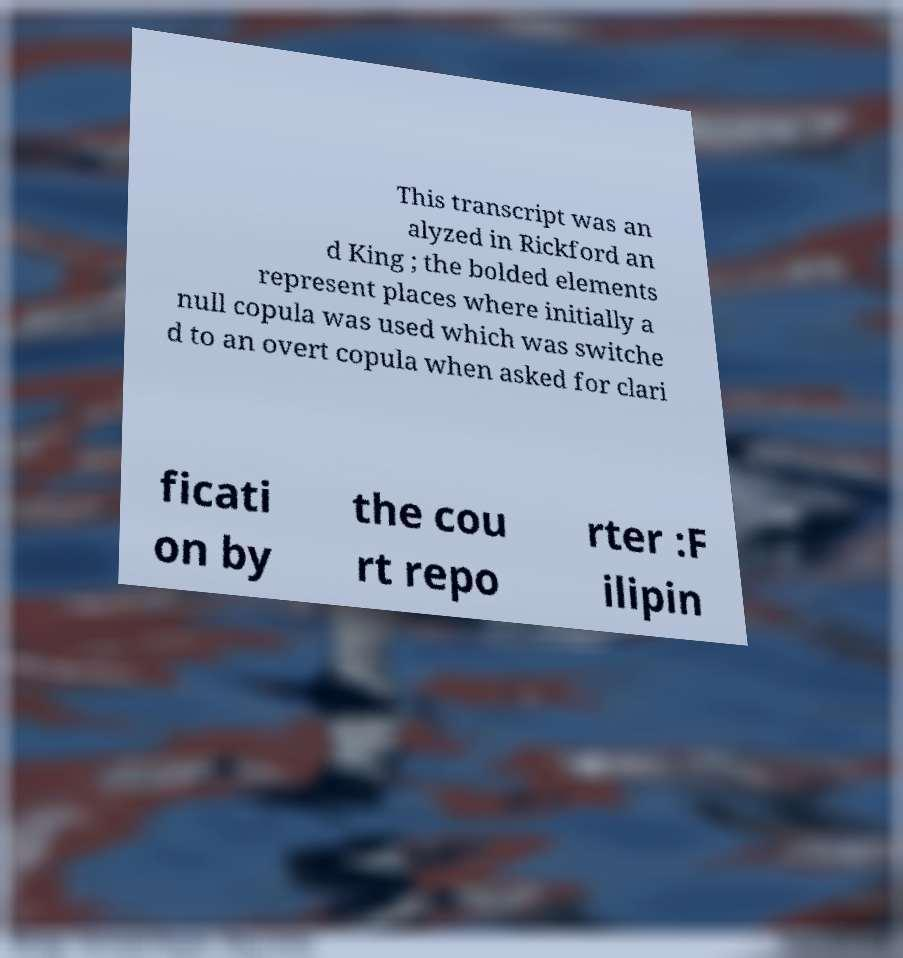Can you accurately transcribe the text from the provided image for me? This transcript was an alyzed in Rickford an d King ; the bolded elements represent places where initially a null copula was used which was switche d to an overt copula when asked for clari ficati on by the cou rt repo rter :F ilipin 